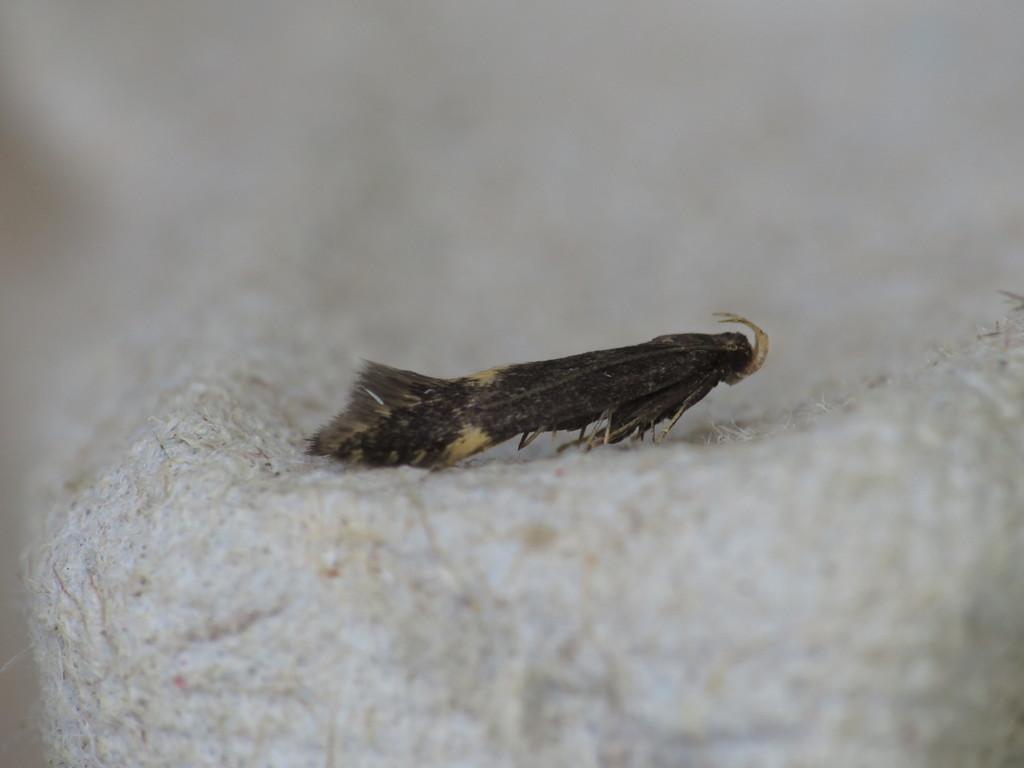What type of creature is in the image? There is an insect in the image. Can you describe the color of the insect? The insect is black and cream in color. What is the insect resting on in the image? The insect is on a white colored object. How would you describe the background of the image? The background of the image is blurry. What is the price of the mitten in the image? There is no mitten present in the image, so it is not possible to determine its price. 